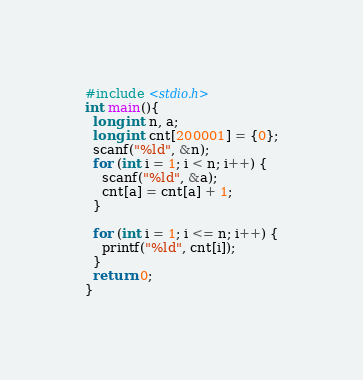Convert code to text. <code><loc_0><loc_0><loc_500><loc_500><_C_>#include <stdio.h>
int main(){
  long int n, a;
  long int cnt[200001] = {0};
  scanf("%ld", &n);
  for (int i = 1; i < n; i++) {
    scanf("%ld", &a);
    cnt[a] = cnt[a] + 1;
  }
  
  for (int i = 1; i <= n; i++) {
    printf("%ld", cnt[i]);
  }
  return 0;
}</code> 